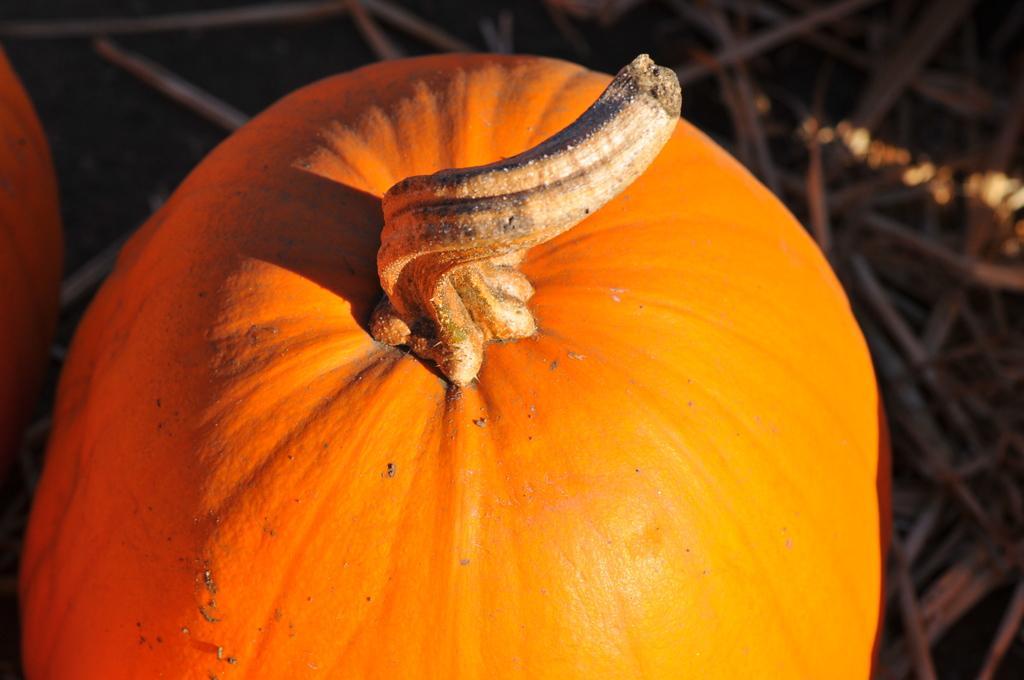Can you describe this image briefly? In this picture we can see a pumpkin in the front, there are some sticks in the background. 